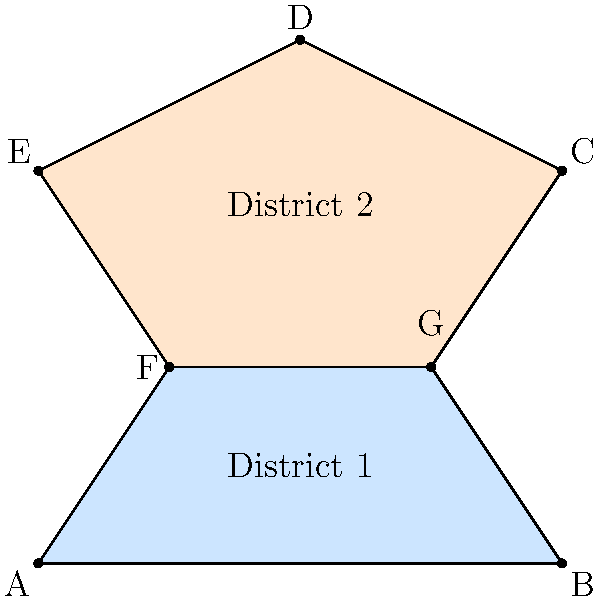In the given map of two voting districts, which shape characteristic is most likely to indicate gerrymandering, and how might it impact election results in Florida? To analyze the impact of district shapes on election results, we need to consider the following steps:

1. Observe the shapes: District 1 is relatively compact, while District 2 has an irregular shape with protrusions.

2. Identify potential gerrymandering indicators:
   a) Irregular shapes: District 2 has a non-compact, convoluted shape.
   b) Unnecessary divisions: The boundary between districts cuts through what could be a unified area.

3. Consider the impact on election results:
   a) Concentration of voters: The irregular shape of District 2 might concentrate certain voter demographics.
   b) Dilution of opposition: District 1's shape might dilute opposition voters across a larger area.

4. Florida context:
   a) Florida has a history of redistricting challenges and court interventions.
   b) The state's diverse population makes it susceptible to gerrymandering attempts.

5. Key indicator: The most likely indicator of gerrymandering is the irregular, non-compact shape of District 2.

6. Potential impact:
   a) Skewed representation: The irregular shape might lead to disproportionate representation.
   b) Reduced competitiveness: Carefully drawn boundaries could create "safe" districts for incumbents.
   c) Voter confusion: Complex shapes might confuse voters about their district.

Therefore, the irregular shape of District 2 is the most likely indicator of gerrymandering, potentially leading to skewed representation and reduced electoral competitiveness in Florida.
Answer: Irregular shape of District 2; potential for skewed representation and reduced competitiveness 